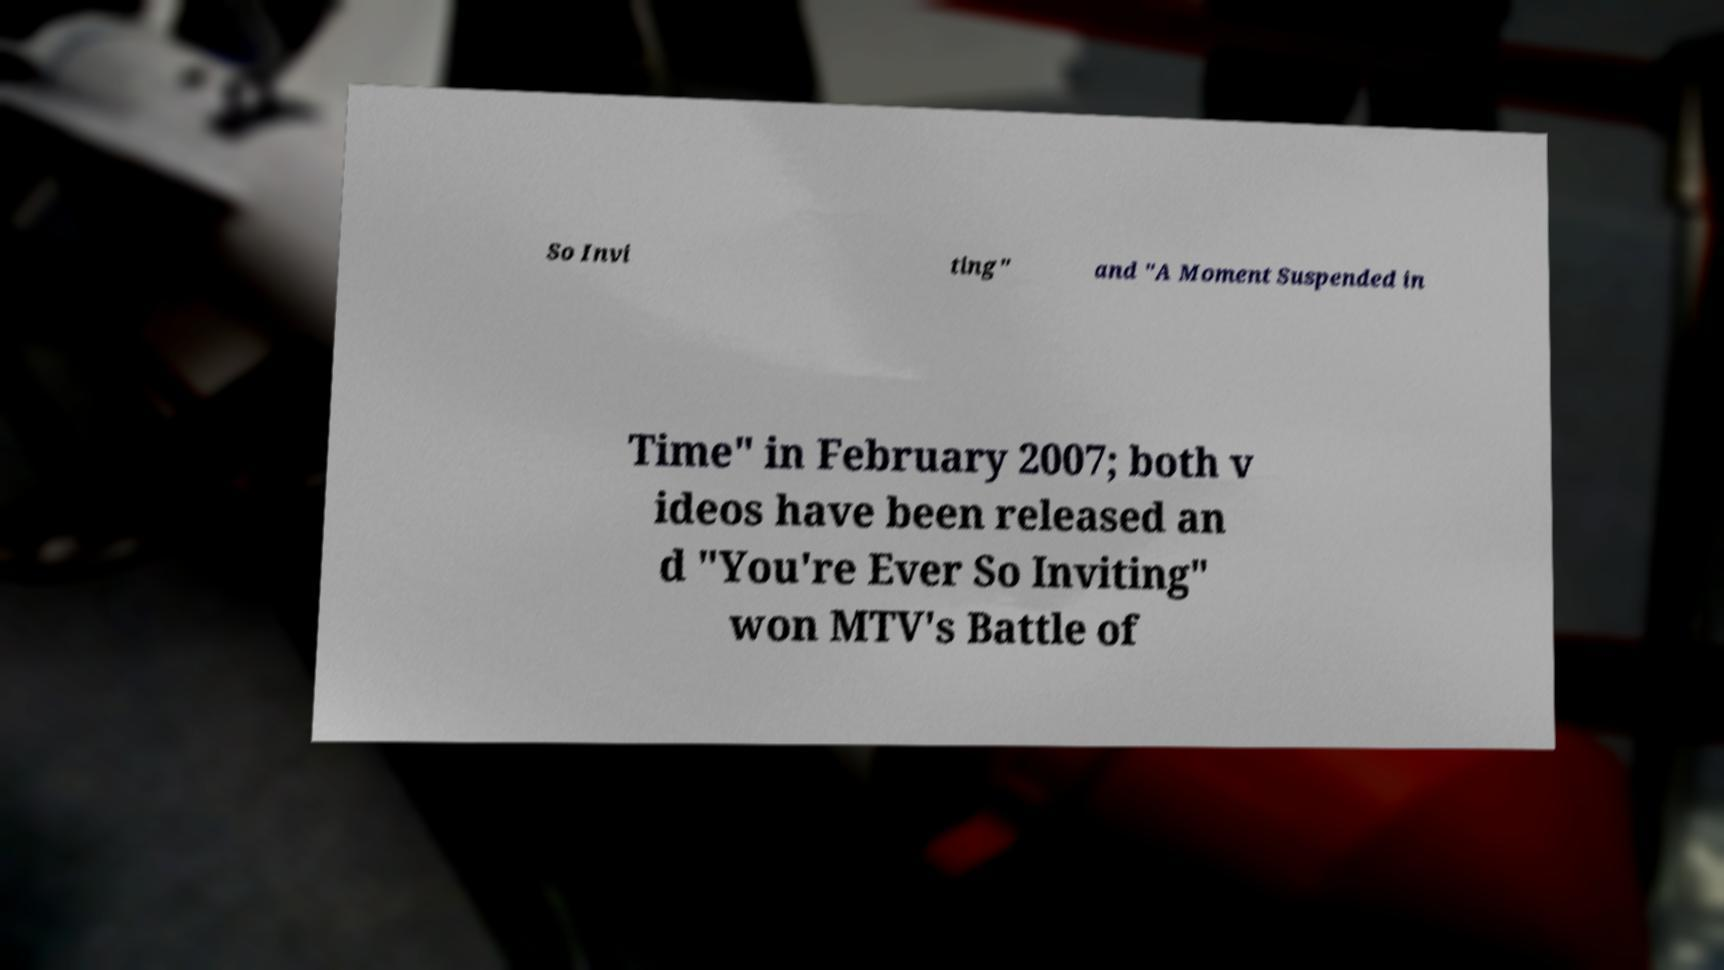Could you assist in decoding the text presented in this image and type it out clearly? So Invi ting" and "A Moment Suspended in Time" in February 2007; both v ideos have been released an d "You're Ever So Inviting" won MTV's Battle of 